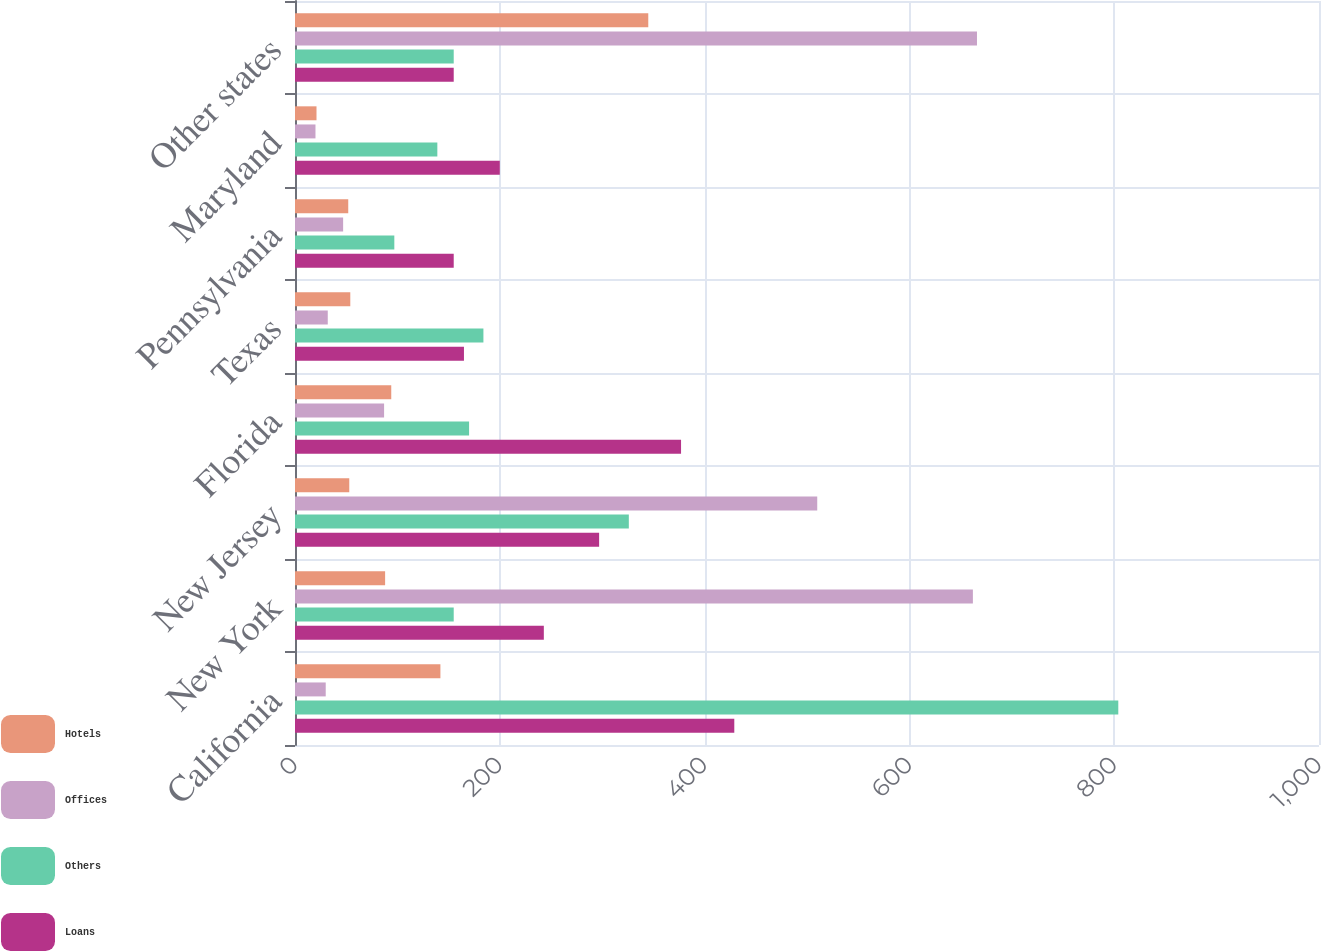Convert chart to OTSL. <chart><loc_0><loc_0><loc_500><loc_500><stacked_bar_chart><ecel><fcel>California<fcel>New York<fcel>New Jersey<fcel>Florida<fcel>Texas<fcel>Pennsylvania<fcel>Maryland<fcel>Other states<nl><fcel>Hotels<fcel>142<fcel>88<fcel>53<fcel>94<fcel>54<fcel>52<fcel>21<fcel>345<nl><fcel>Offices<fcel>30<fcel>662<fcel>510<fcel>87<fcel>32<fcel>47<fcel>20<fcel>666<nl><fcel>Others<fcel>804<fcel>155<fcel>326<fcel>170<fcel>184<fcel>97<fcel>139<fcel>155<nl><fcel>Loans<fcel>429<fcel>243<fcel>297<fcel>377<fcel>165<fcel>155<fcel>200<fcel>155<nl></chart> 